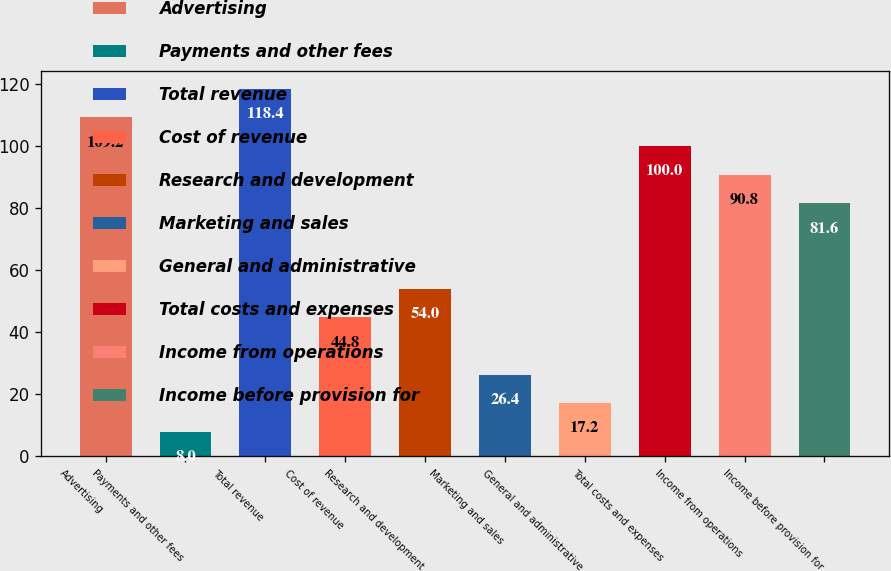Convert chart. <chart><loc_0><loc_0><loc_500><loc_500><bar_chart><fcel>Advertising<fcel>Payments and other fees<fcel>Total revenue<fcel>Cost of revenue<fcel>Research and development<fcel>Marketing and sales<fcel>General and administrative<fcel>Total costs and expenses<fcel>Income from operations<fcel>Income before provision for<nl><fcel>109.2<fcel>8<fcel>118.4<fcel>44.8<fcel>54<fcel>26.4<fcel>17.2<fcel>100<fcel>90.8<fcel>81.6<nl></chart> 